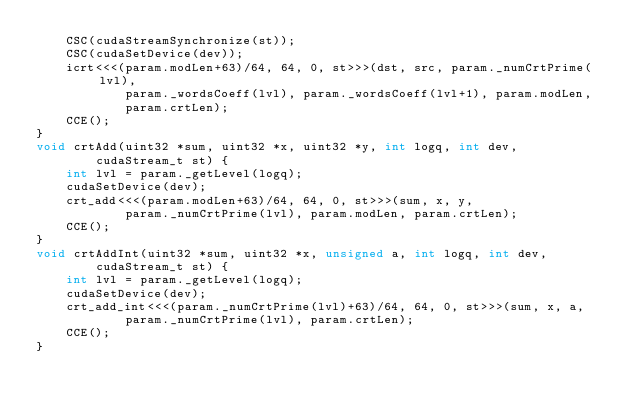<code> <loc_0><loc_0><loc_500><loc_500><_Cuda_>	CSC(cudaStreamSynchronize(st));
	CSC(cudaSetDevice(dev));
	icrt<<<(param.modLen+63)/64, 64, 0, st>>>(dst, src, param._numCrtPrime(lvl),
			param._wordsCoeff(lvl), param._wordsCoeff(lvl+1), param.modLen,
			param.crtLen);
	CCE();
}
void crtAdd(uint32 *sum, uint32 *x, uint32 *y, int logq, int dev,
		cudaStream_t st) {
	int lvl = param._getLevel(logq);
	cudaSetDevice(dev);
	crt_add<<<(param.modLen+63)/64, 64, 0, st>>>(sum, x, y,
			param._numCrtPrime(lvl), param.modLen, param.crtLen);
	CCE();
}
void crtAddInt(uint32 *sum, uint32 *x, unsigned a, int logq, int dev,
		cudaStream_t st) {
	int lvl = param._getLevel(logq);
	cudaSetDevice(dev);
	crt_add_int<<<(param._numCrtPrime(lvl)+63)/64, 64, 0, st>>>(sum, x, a,
			param._numCrtPrime(lvl), param.crtLen);
	CCE();
}</code> 